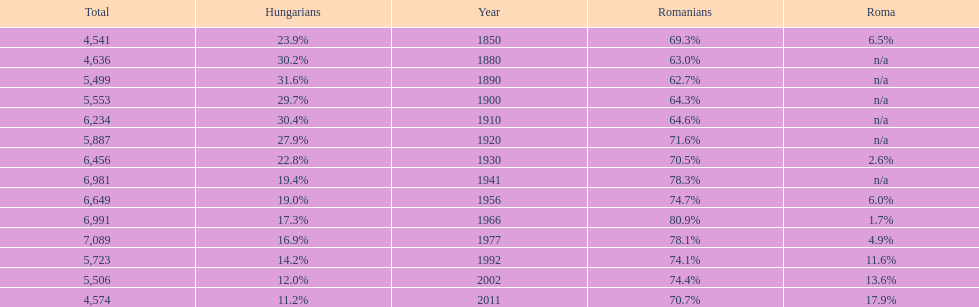What year had the next highest percentage for roma after 2011? 2002. 